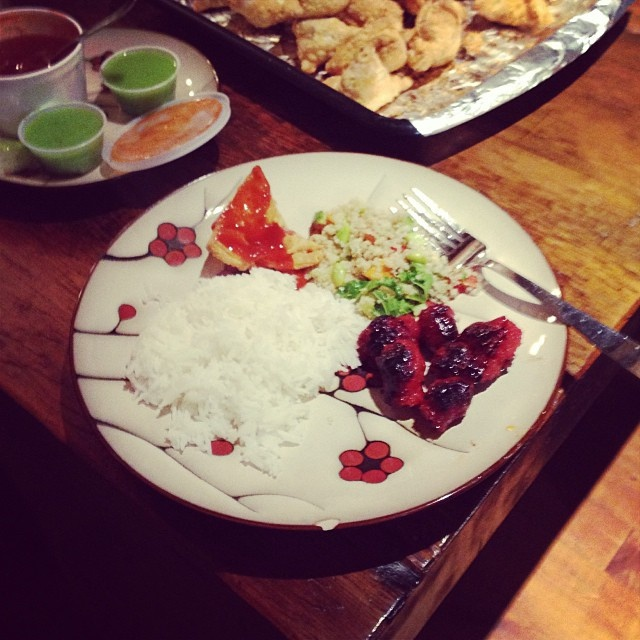Describe the objects in this image and their specific colors. I can see dining table in black, beige, maroon, and brown tones, bowl in black, maroon, and gray tones, fork in black, beige, and purple tones, bowl in black, darkgreen, gray, and darkgray tones, and cup in black, darkgreen, and gray tones in this image. 